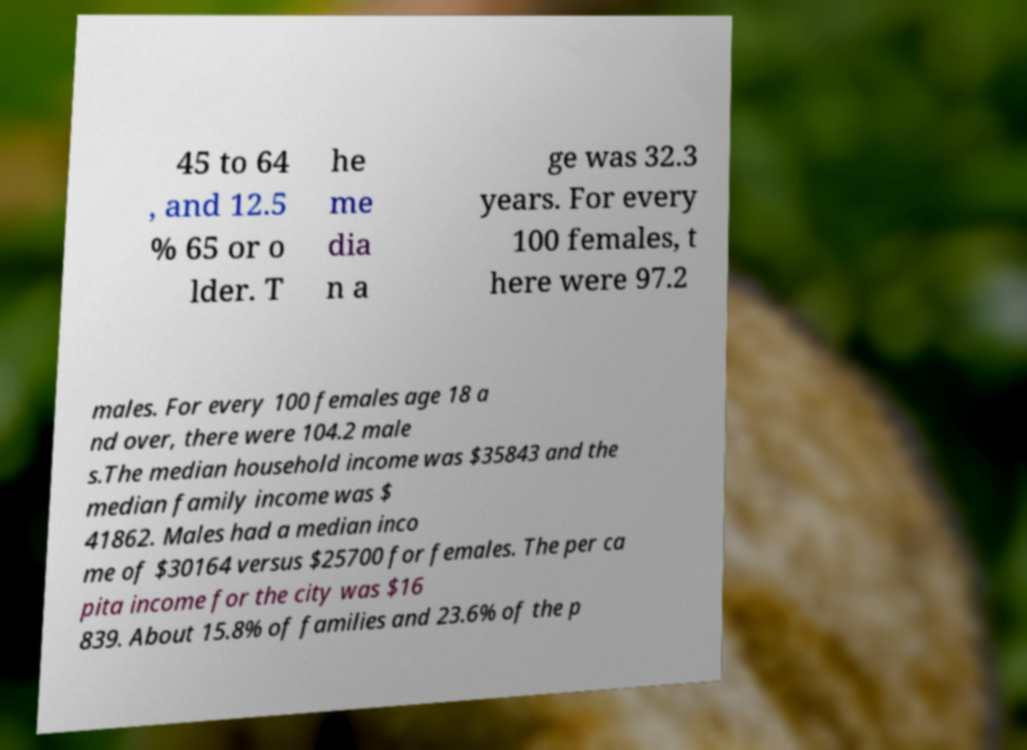Could you assist in decoding the text presented in this image and type it out clearly? 45 to 64 , and 12.5 % 65 or o lder. T he me dia n a ge was 32.3 years. For every 100 females, t here were 97.2 males. For every 100 females age 18 a nd over, there were 104.2 male s.The median household income was $35843 and the median family income was $ 41862. Males had a median inco me of $30164 versus $25700 for females. The per ca pita income for the city was $16 839. About 15.8% of families and 23.6% of the p 